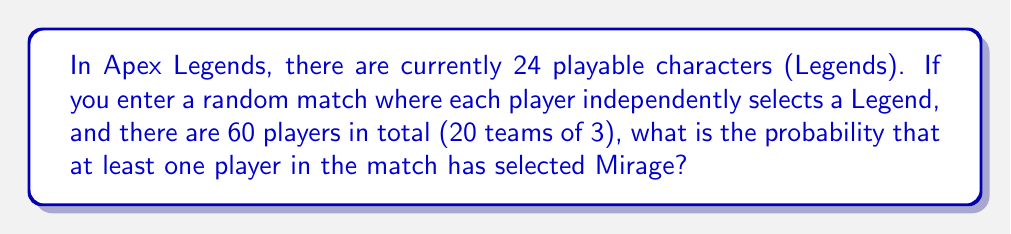Can you solve this math problem? Let's approach this step-by-step:

1) First, let's calculate the probability of a single player not selecting Mirage:
   $P(\text{not Mirage}) = \frac{23}{24} = 0.9583$

2) For Mirage to not be in the match at all, all 60 players must not select him. The probability of this is:
   $P(\text{no Mirage}) = (\frac{23}{24})^{60} \approx 0.0778$

3) Therefore, the probability of at least one Mirage in the match is the complement of this probability:
   $P(\text{at least one Mirage}) = 1 - P(\text{no Mirage})$
   $= 1 - (\frac{23}{24})^{60}$
   $\approx 1 - 0.0778$
   $\approx 0.9222$

4) Converting to a percentage:
   $0.9222 \times 100\% = 92.22\%$

Thus, there is approximately a 92.22% chance of encountering at least one Mirage in a random match.
Answer: $92.22\%$ 